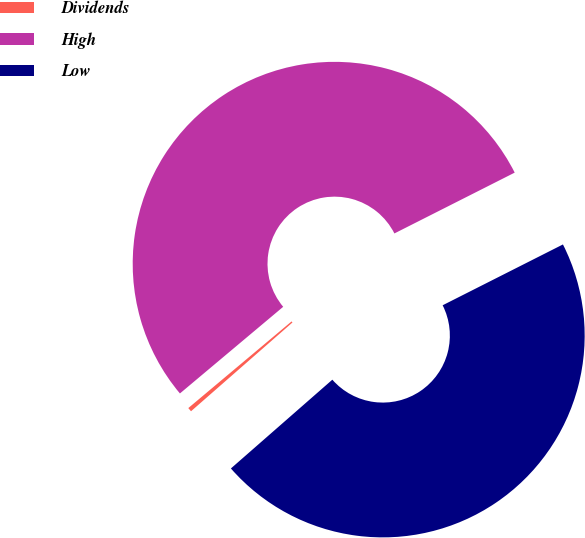Convert chart. <chart><loc_0><loc_0><loc_500><loc_500><pie_chart><fcel>Dividends<fcel>High<fcel>Low<nl><fcel>0.33%<fcel>53.66%<fcel>46.01%<nl></chart> 